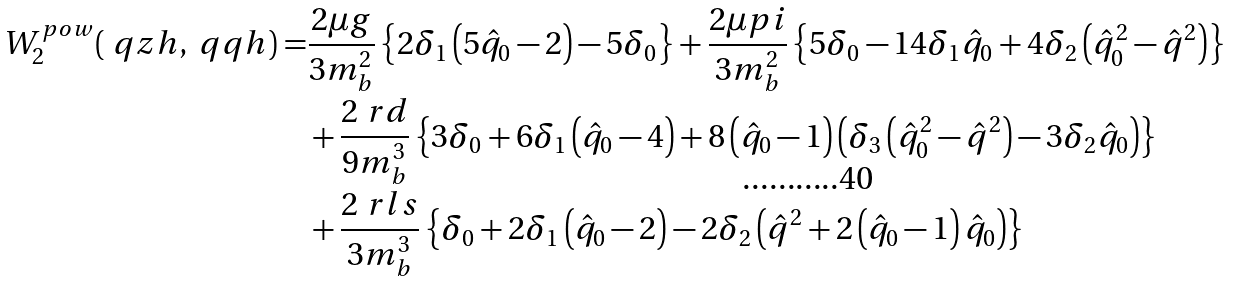Convert formula to latex. <formula><loc_0><loc_0><loc_500><loc_500>W _ { 2 } ^ { p o w } ( \ q z h , \ q q h ) = & \frac { 2 \mu g } { 3 m _ { b } ^ { 2 } } \left \{ 2 \delta _ { 1 } \left ( 5 \hat { q } _ { 0 } - 2 \right ) - 5 \delta _ { 0 } \right \} + \frac { 2 \mu p i } { 3 m _ { b } ^ { 2 } } \left \{ 5 \delta _ { 0 } - 1 4 \delta _ { 1 } \hat { q } _ { 0 } + 4 \delta _ { 2 } \left ( \hat { q } _ { 0 } ^ { 2 } - \hat { q } ^ { 2 } \right ) \right \} \\ & + \frac { 2 \ r d } { 9 m _ { b } ^ { 3 } } \left \{ 3 \delta _ { 0 } + 6 \delta _ { 1 } \left ( \hat { q } _ { 0 } - 4 \right ) + 8 \left ( \hat { q } _ { 0 } - 1 \right ) \left ( \delta _ { 3 } \left ( \hat { q } _ { 0 } ^ { 2 } - \hat { q } ^ { 2 } \right ) - 3 \delta _ { 2 } \hat { q } _ { 0 } \right ) \right \} \\ & + \frac { 2 \ r l s } { 3 m _ { b } ^ { 3 } } \left \{ \delta _ { 0 } + 2 \delta _ { 1 } \left ( \hat { q } _ { 0 } - 2 \right ) - 2 \delta _ { 2 } \left ( \hat { q } ^ { 2 } + 2 \left ( \hat { q } _ { 0 } - 1 \right ) \hat { q } _ { 0 } \right ) \right \}</formula> 